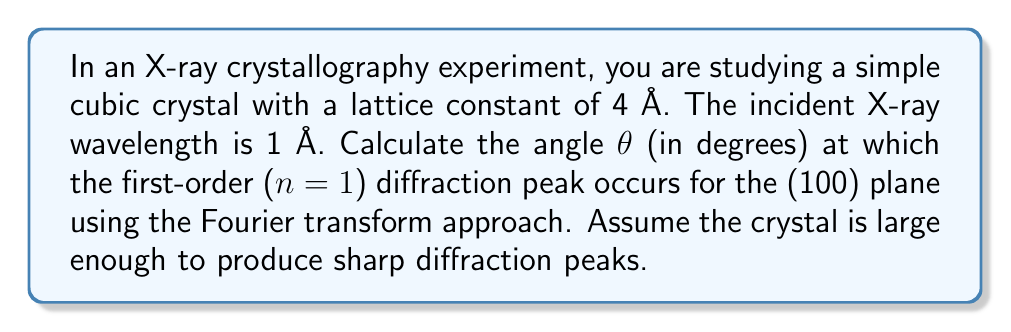Show me your answer to this math problem. To solve this problem, we'll follow these steps:

1) In X-ray crystallography, the diffraction pattern is essentially the Fourier transform of the electron density in the crystal. The peaks in the diffraction pattern correspond to the reciprocal lattice vectors of the crystal structure.

2) For a simple cubic crystal, the reciprocal lattice vectors are given by:

   $$\mathbf{G} = \frac{2\pi}{a}(h\hat{x} + k\hat{y} + l\hat{z})$$

   where $a$ is the lattice constant, and $h$, $k$, and $l$ are integers.

3) The condition for constructive interference (diffraction peak) is given by the Laue condition:

   $$\mathbf{k}' - \mathbf{k} = \mathbf{G}$$

   where $\mathbf{k}'$ and $\mathbf{k}$ are the wavevectors of the scattered and incident X-rays, respectively.

4) The magnitude of the wavevector is related to the wavelength:

   $$|\mathbf{k}| = |\mathbf{k}'| = \frac{2\pi}{\lambda}$$

5) For the (100) plane, $h=1$, $k=0$, $l=0$. So the magnitude of $\mathbf{G}$ is:

   $$|\mathbf{G}| = \frac{2\pi}{a}$$

6) The Laue condition in scalar form becomes:

   $$2|\mathbf{k}|\sin(\theta) = |\mathbf{G}|$$

7) Substituting the values:

   $$2\cdot\frac{2\pi}{\lambda}\sin(\theta) = \frac{2\pi}{a}$$

8) Simplifying:

   $$\sin(\theta) = \frac{\lambda}{2a}$$

9) Substituting the given values ($\lambda = 1$ Å, $a = 4$ Å):

   $$\sin(\theta) = \frac{1}{2\cdot4} = \frac{1}{8}$$

10) Taking the inverse sine and converting to degrees:

    $$\theta = \arcsin(\frac{1}{8}) \cdot \frac{180}{\pi}$$
Answer: $\theta \approx 7.18°$ 